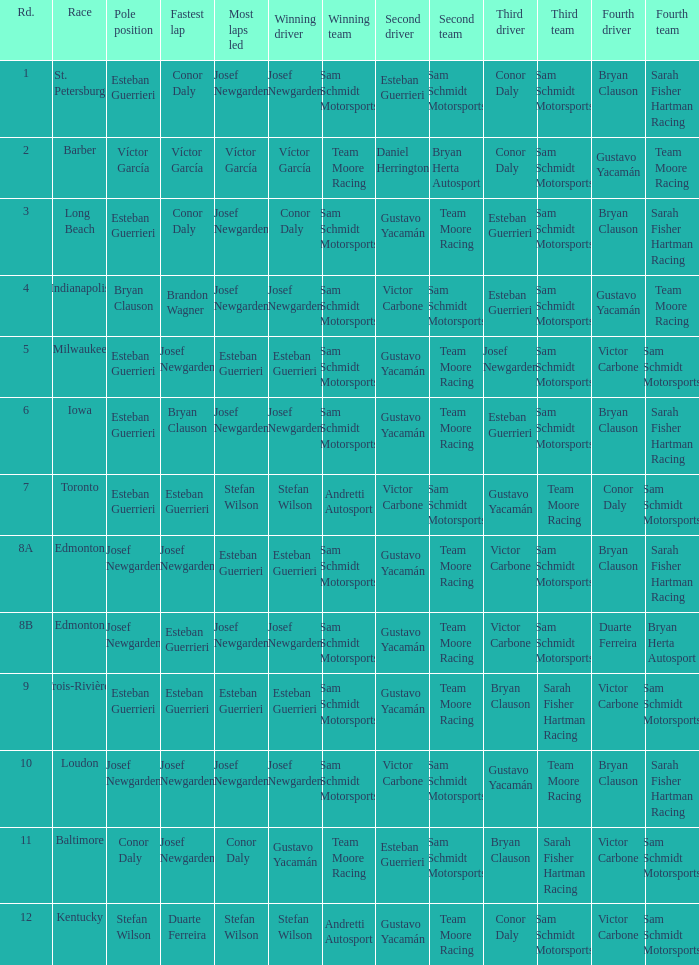Who had the fastest lap(s) when stefan wilson had the pole? Duarte Ferreira. 